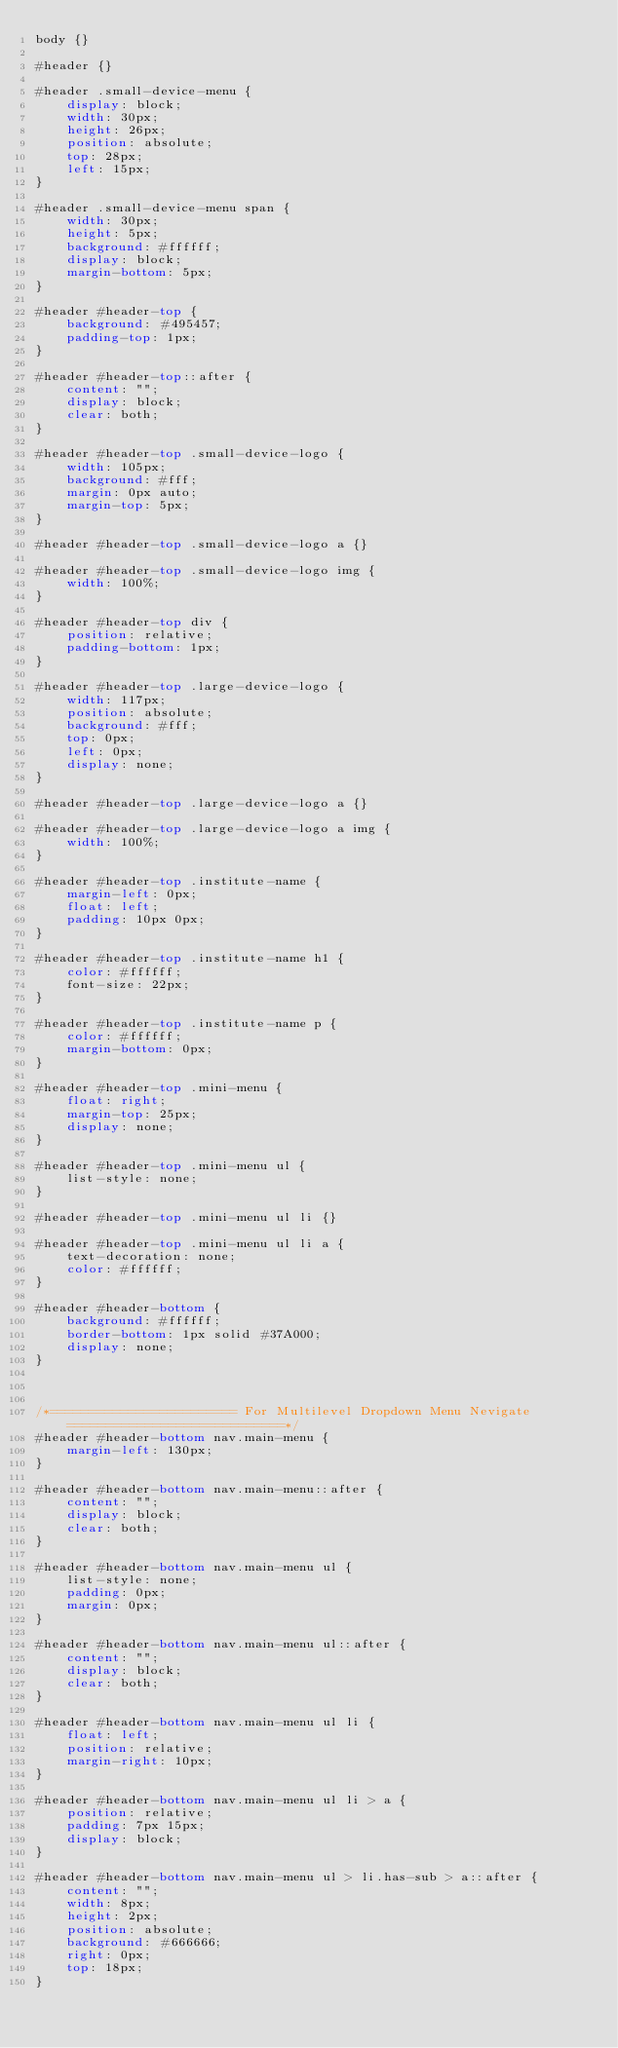<code> <loc_0><loc_0><loc_500><loc_500><_CSS_>body {}

#header {}

#header .small-device-menu {
    display: block;
    width: 30px;
    height: 26px;
    position: absolute;
    top: 28px;
    left: 15px;
}

#header .small-device-menu span {
    width: 30px;
    height: 5px;
    background: #ffffff;
    display: block;
    margin-bottom: 5px;
}

#header #header-top {
    background: #495457;
    padding-top: 1px;
}

#header #header-top::after {
    content: "";
    display: block;
    clear: both;
}

#header #header-top .small-device-logo {
    width: 105px;
    background: #fff;
    margin: 0px auto;
    margin-top: 5px;
}

#header #header-top .small-device-logo a {}

#header #header-top .small-device-logo img {
    width: 100%;
}

#header #header-top div {
    position: relative;
    padding-bottom: 1px;
}

#header #header-top .large-device-logo {
    width: 117px;
    position: absolute;
    background: #fff;
    top: 0px;
    left: 0px;
    display: none;
}

#header #header-top .large-device-logo a {}

#header #header-top .large-device-logo a img {
    width: 100%;
}

#header #header-top .institute-name {
    margin-left: 0px;
    float: left;
    padding: 10px 0px;
}

#header #header-top .institute-name h1 {
    color: #ffffff;
    font-size: 22px;
}

#header #header-top .institute-name p {
    color: #ffffff;
    margin-bottom: 0px;
}

#header #header-top .mini-menu {
    float: right;
    margin-top: 25px;
    display: none;
}

#header #header-top .mini-menu ul {
    list-style: none;
}

#header #header-top .mini-menu ul li {}

#header #header-top .mini-menu ul li a {
    text-decoration: none;
    color: #ffffff;
}

#header #header-bottom {
    background: #ffffff;
    border-bottom: 1px solid #37A000;
    display: none;
}



/*======================== For Multilevel Dropdown Menu Nevigate============================*/
#header #header-bottom nav.main-menu {
    margin-left: 130px;
}

#header #header-bottom nav.main-menu::after {
    content: "";
    display: block;
    clear: both;
}

#header #header-bottom nav.main-menu ul {
    list-style: none;
    padding: 0px;
    margin: 0px;
}

#header #header-bottom nav.main-menu ul::after {
    content: "";
    display: block;
    clear: both;
}

#header #header-bottom nav.main-menu ul li {
    float: left;
    position: relative;
    margin-right: 10px;
}

#header #header-bottom nav.main-menu ul li > a {
    position: relative;
    padding: 7px 15px;
    display: block;
}

#header #header-bottom nav.main-menu ul > li.has-sub > a::after {
    content: "";
    width: 8px;
    height: 2px;
    position: absolute;
    background: #666666;
    right: 0px;
    top: 18px;
}
</code> 